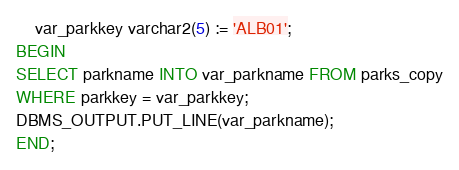<code> <loc_0><loc_0><loc_500><loc_500><_SQL_>	var_parkkey varchar2(5) := 'ALB01'; 
BEGIN
SELECT parkname INTO var_parkname FROM parks_copy
WHERE parkkey = var_parkkey; 
DBMS_OUTPUT.PUT_LINE(var_parkname);
END; 
</code> 